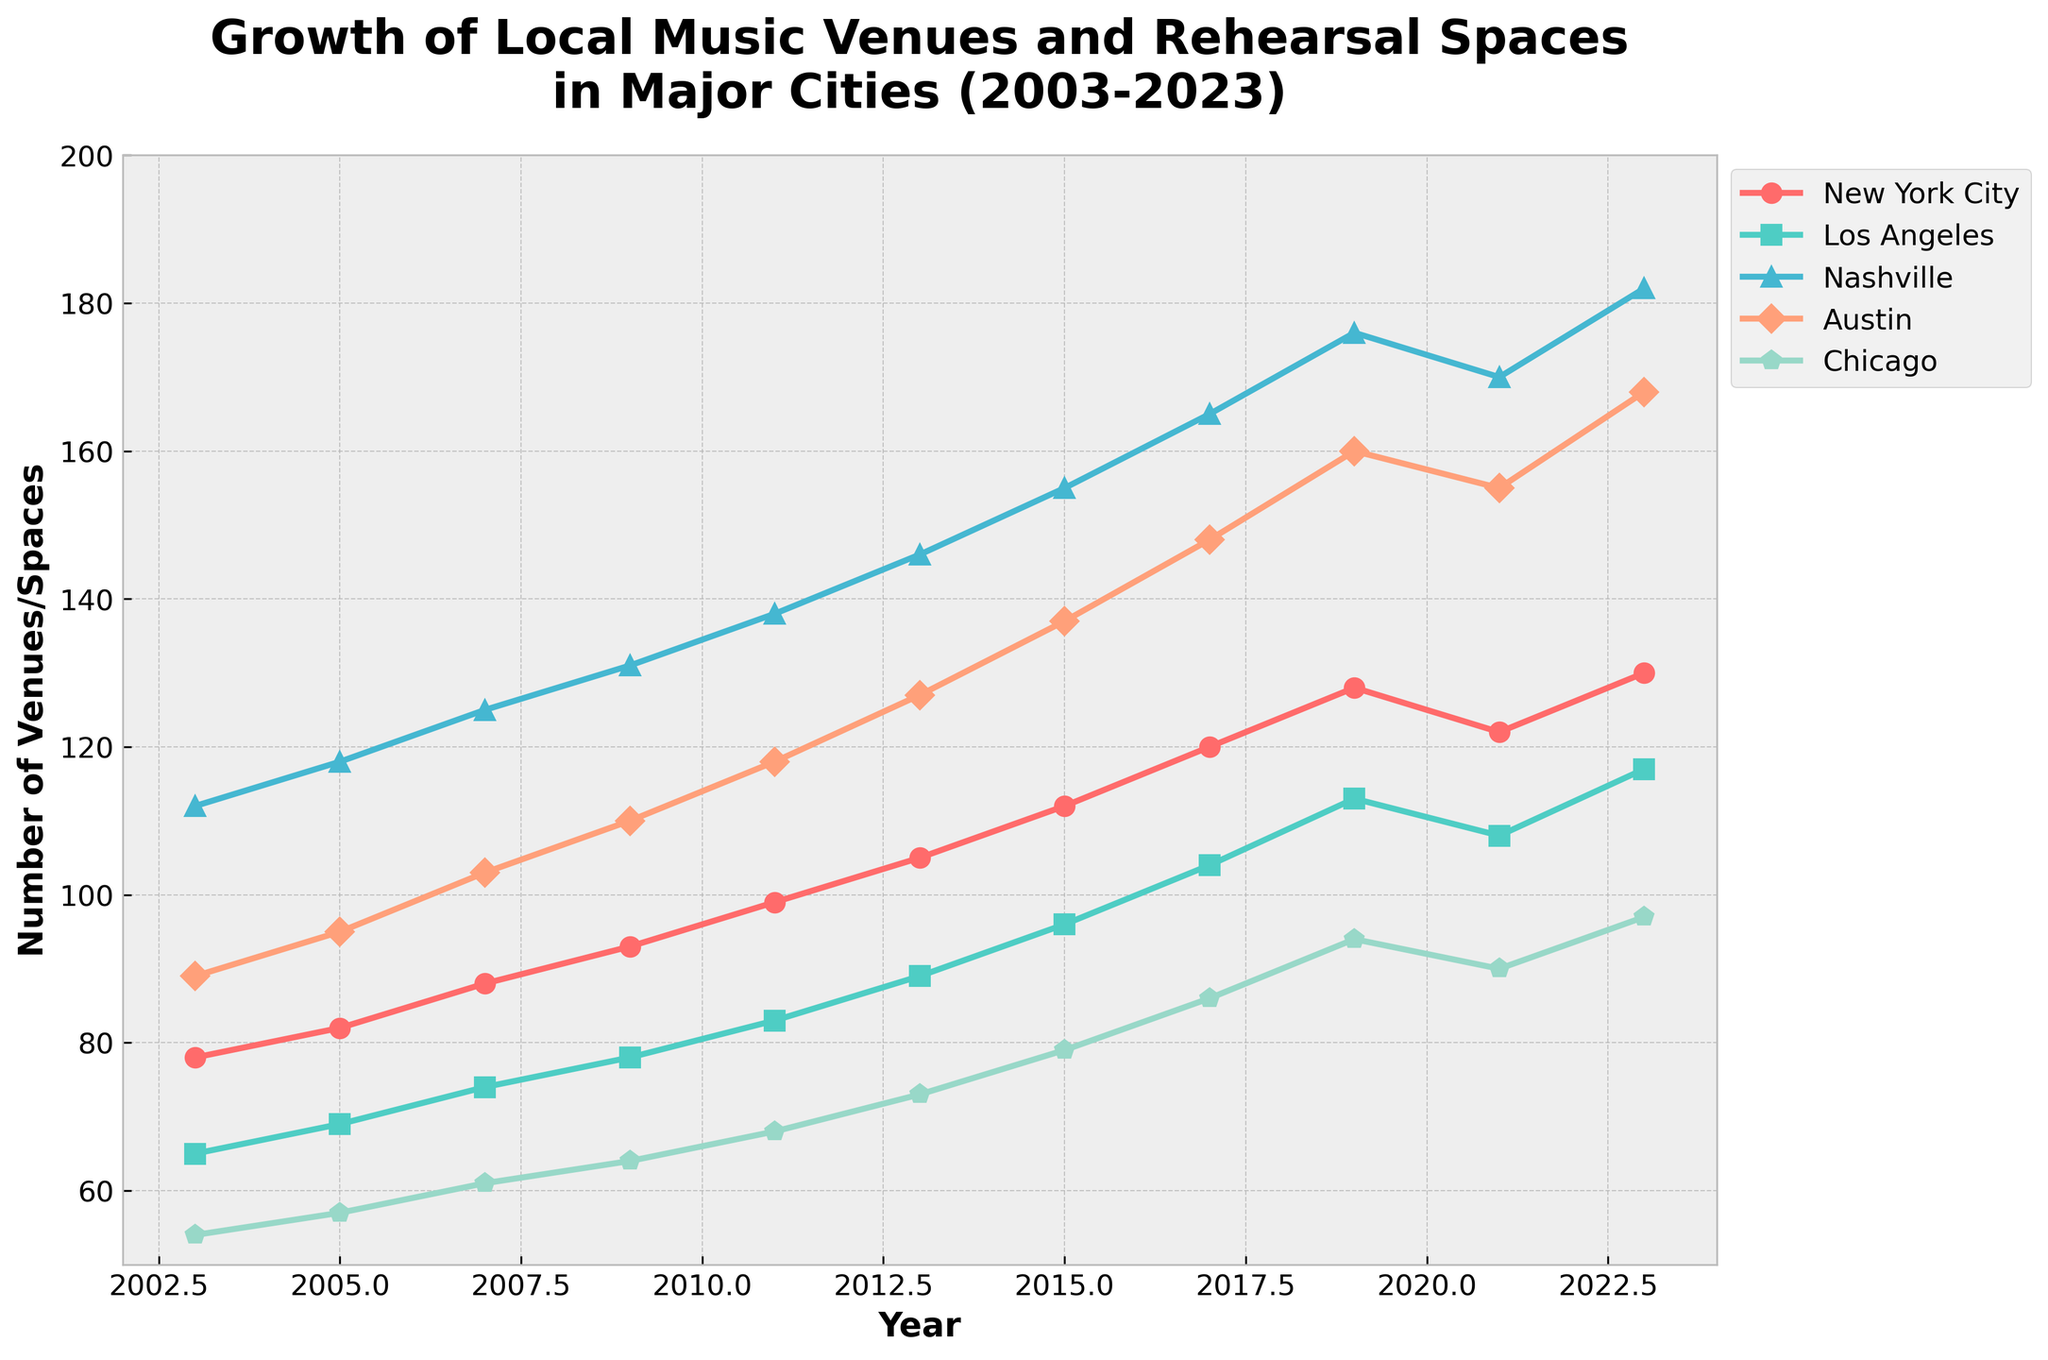Which city saw the highest growth in the number of music venues and rehearsal spaces between 2003 and 2023? Calculate the growth for each city by subtracting the 2003 value from the 2023 value. New York City: 130-78=52, Los Angeles: 117-65=52, Nashville: 182-112=70, Austin: 168-89=79, Chicago: 97-54=43. Thus, Austin saw the highest growth.
Answer: Austin By how much did the number of music venues and rehearsal spaces in Los Angeles increase from 2009 to 2017? Subtract the 2009 value from the 2017 value for Los Angeles: 104-78=26.
Answer: 26 Which two cities had the closest number of music venues and rehearsal spaces in 2023? Compare the 2023 values: New York City: 130, Los Angeles: 117, Nashville: 182, Austin: 168, Chicago: 97. The closest numbers are New York City (130) and Los Angeles (117).
Answer: New York City and Los Angeles In 2013, which city had the second highest number of music venues and rehearsal spaces? Compare the 2013 values: New York City: 105, Los Angeles: 89, Nashville: 146, Austin: 127, Chicago: 73. The second highest number is 127 for Austin.
Answer: Austin What was the average number of music venues and rehearsal spaces in Chicago over the entire period (2003-2023)? Sum the values for Chicago and divide by the number of data points: (54+57+61+64+68+73+79+86+94+90+97)/11. The calculation is 723/11=65.73.
Answer: 65.73 How many times did Austin surpass the 100 mark for music venues and rehearsal spaces in the given years? Identify the years where Austin's value is greater than 100: Since 2013 (127, 137, 148, 160, 155, 168). The count is 6 times.
Answer: 6 Which city had the steepest increase in music venues and rehearsal spaces between any two consecutive data points, and what was the increase? For each city, calculate the increase between consecutive data points and find the maximum. Nashville's steepest increase is between 2019 (176) and 2023 (182), which is 182-176=6. Other cities have smaller increases, making Nashville's increase the steepest.
Answer: Nashville, 6 In which year did New York City overtake 100 music venues and rehearsal spaces for the first time? Identify the first year where the New York City value exceeds 100: In 2015 (112).
Answer: 2015 By the end of the period, which city’s number of music venues and rehearsal spaces showed a decline from its peak within these years? Compare values towards the end and identify any declines. New York City (peak 2019 at 128, 2021 dropped to 122 but increased again to 130 in 2023). Los Angeles shows a decline from its peak 2019 at 113 to 2021 but then increased to 117 in 2023. Meanwhile, values for others show consistent growth. Los Angeles showed a temporary decline.
Answer: Los Angeles 